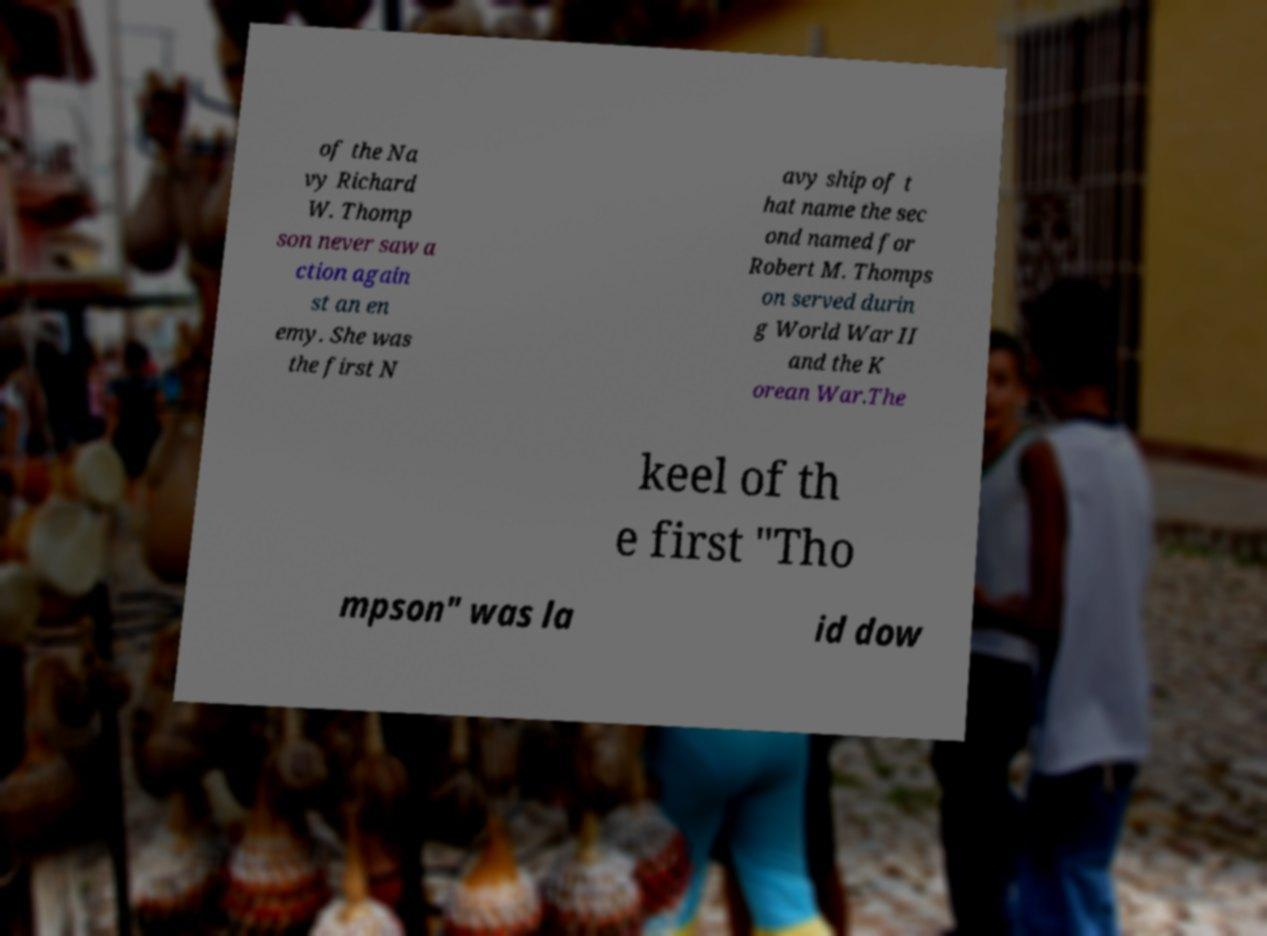For documentation purposes, I need the text within this image transcribed. Could you provide that? of the Na vy Richard W. Thomp son never saw a ction again st an en emy. She was the first N avy ship of t hat name the sec ond named for Robert M. Thomps on served durin g World War II and the K orean War.The keel of th e first "Tho mpson" was la id dow 